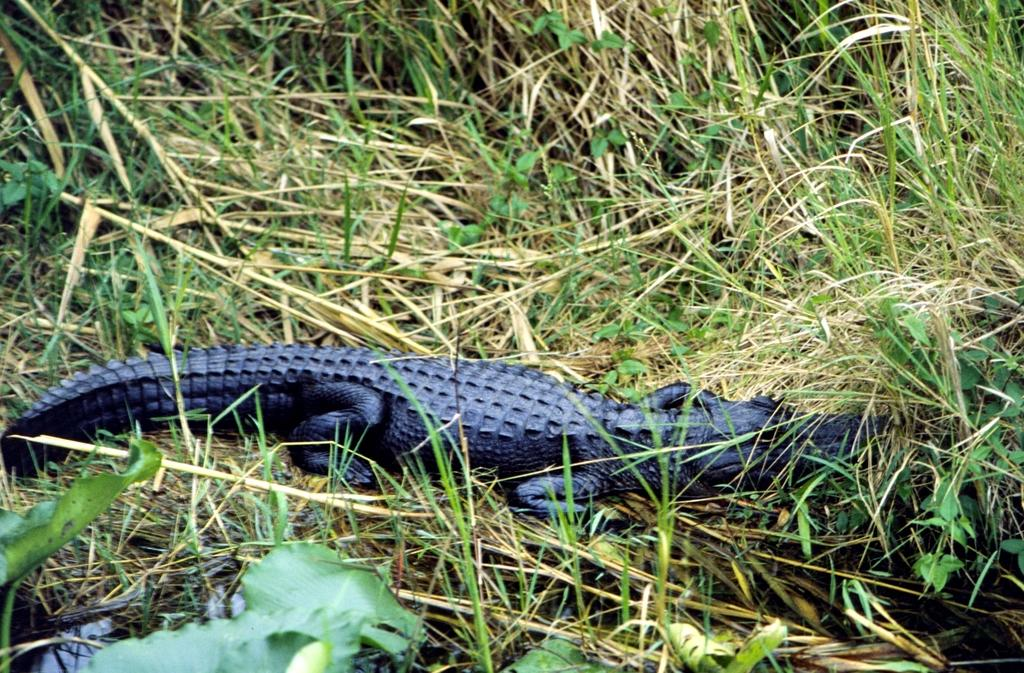What animal can be seen on the grass in the image? There is a crocodile on the grass in the image. What can be found at the bottom of the image? There are plants in the water at the bottom of the image. Where are more plants located in the image? There are plants on the right side of the image. What type of suggestion can be seen in the image? There is no suggestion present in the image; it features a crocodile on the grass and plants in the water and on the right side. 